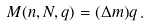Convert formula to latex. <formula><loc_0><loc_0><loc_500><loc_500>M ( n , N , q ) = ( \Delta m ) q \, .</formula> 